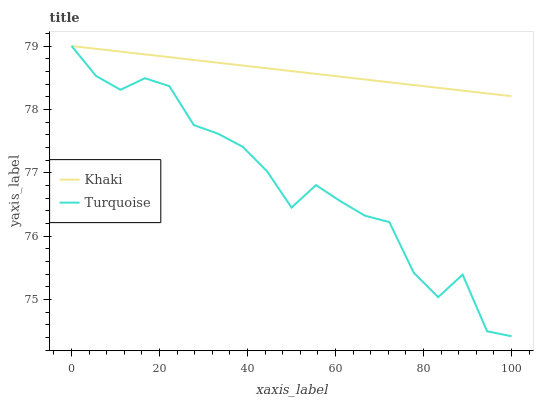Does Turquoise have the minimum area under the curve?
Answer yes or no. Yes. Does Khaki have the maximum area under the curve?
Answer yes or no. Yes. Does Khaki have the minimum area under the curve?
Answer yes or no. No. Is Khaki the smoothest?
Answer yes or no. Yes. Is Turquoise the roughest?
Answer yes or no. Yes. Is Khaki the roughest?
Answer yes or no. No. Does Khaki have the lowest value?
Answer yes or no. No. Does Khaki have the highest value?
Answer yes or no. Yes. Does Turquoise intersect Khaki?
Answer yes or no. Yes. Is Turquoise less than Khaki?
Answer yes or no. No. Is Turquoise greater than Khaki?
Answer yes or no. No. 